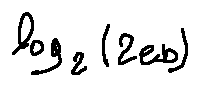Convert formula to latex. <formula><loc_0><loc_0><loc_500><loc_500>\log _ { 2 } ( 2 e b )</formula> 